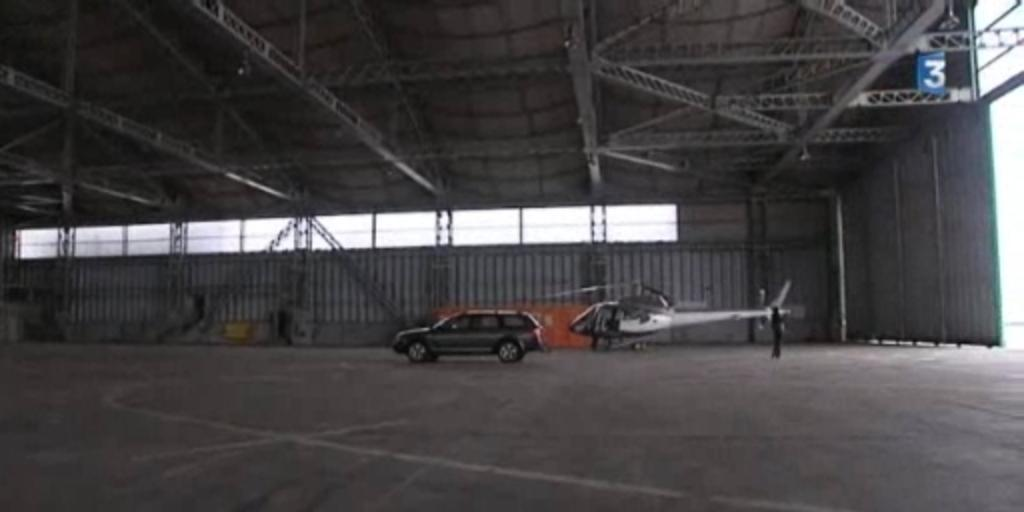Provide a one-sentence caption for the provided image. An SUV and a helicopter are sitting inside a large empty hangar number 3. 